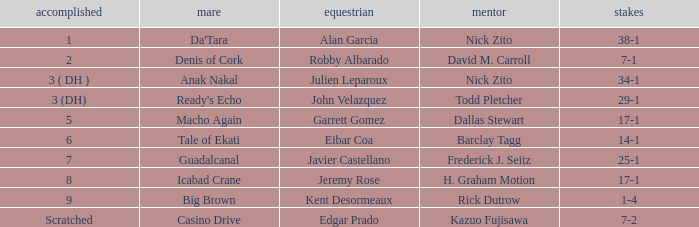Parse the full table. {'header': ['accomplished', 'mare', 'equestrian', 'mentor', 'stakes'], 'rows': [['1', "Da'Tara", 'Alan Garcia', 'Nick Zito', '38-1'], ['2', 'Denis of Cork', 'Robby Albarado', 'David M. Carroll', '7-1'], ['3 ( DH )', 'Anak Nakal', 'Julien Leparoux', 'Nick Zito', '34-1'], ['3 (DH)', "Ready's Echo", 'John Velazquez', 'Todd Pletcher', '29-1'], ['5', 'Macho Again', 'Garrett Gomez', 'Dallas Stewart', '17-1'], ['6', 'Tale of Ekati', 'Eibar Coa', 'Barclay Tagg', '14-1'], ['7', 'Guadalcanal', 'Javier Castellano', 'Frederick J. Seitz', '25-1'], ['8', 'Icabad Crane', 'Jeremy Rose', 'H. Graham Motion', '17-1'], ['9', 'Big Brown', 'Kent Desormeaux', 'Rick Dutrow', '1-4'], ['Scratched', 'Casino Drive', 'Edgar Prado', 'Kazuo Fujisawa', '7-2']]} Who is the Jockey that has Nick Zito as Trainer and Odds of 34-1? Julien Leparoux. 